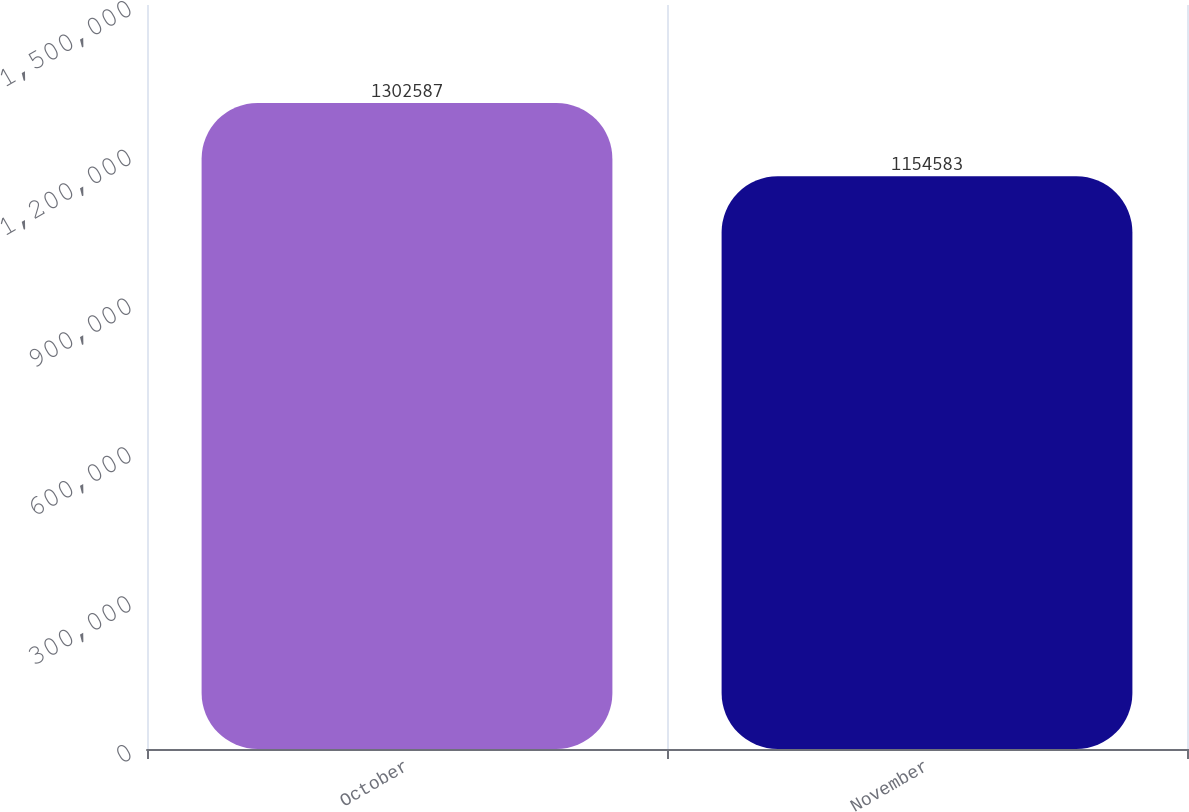Convert chart to OTSL. <chart><loc_0><loc_0><loc_500><loc_500><bar_chart><fcel>October<fcel>November<nl><fcel>1.30259e+06<fcel>1.15458e+06<nl></chart> 